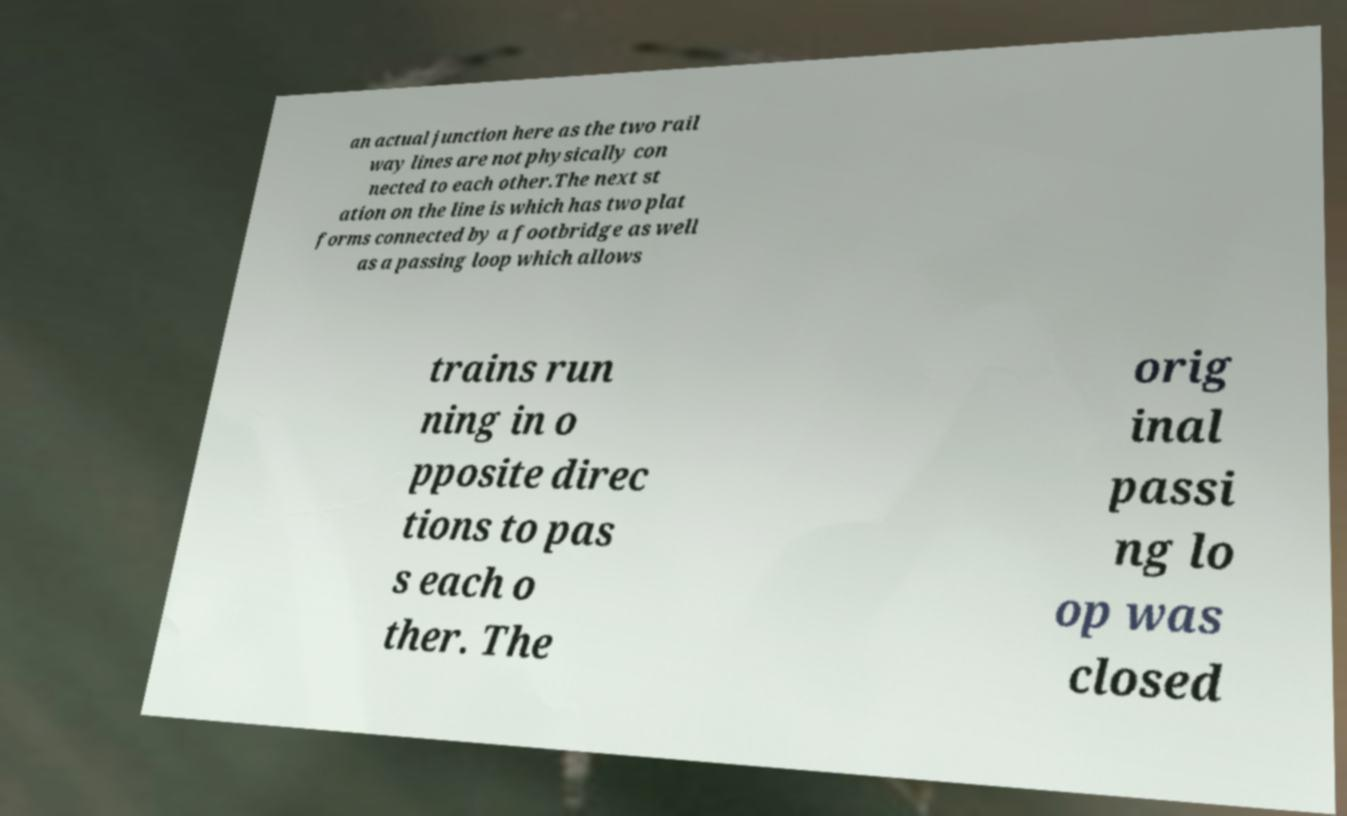There's text embedded in this image that I need extracted. Can you transcribe it verbatim? an actual junction here as the two rail way lines are not physically con nected to each other.The next st ation on the line is which has two plat forms connected by a footbridge as well as a passing loop which allows trains run ning in o pposite direc tions to pas s each o ther. The orig inal passi ng lo op was closed 